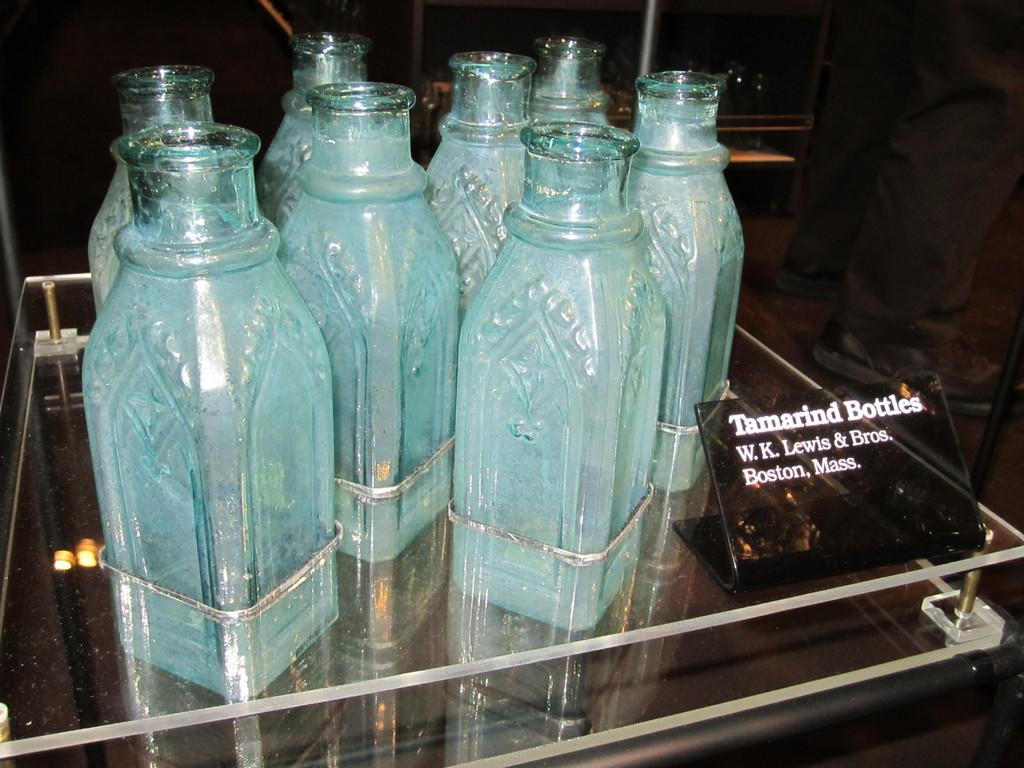<image>
Present a compact description of the photo's key features. A bunch of Tamarind Bottles from W.K. Lewis & Bros from Boston, Mass. 